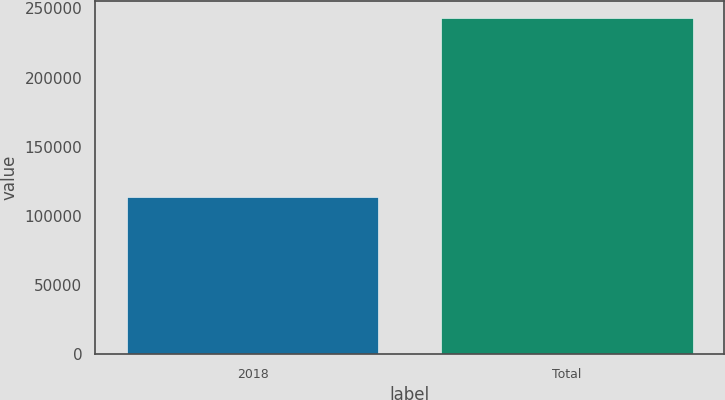<chart> <loc_0><loc_0><loc_500><loc_500><bar_chart><fcel>2018<fcel>Total<nl><fcel>113766<fcel>243135<nl></chart> 